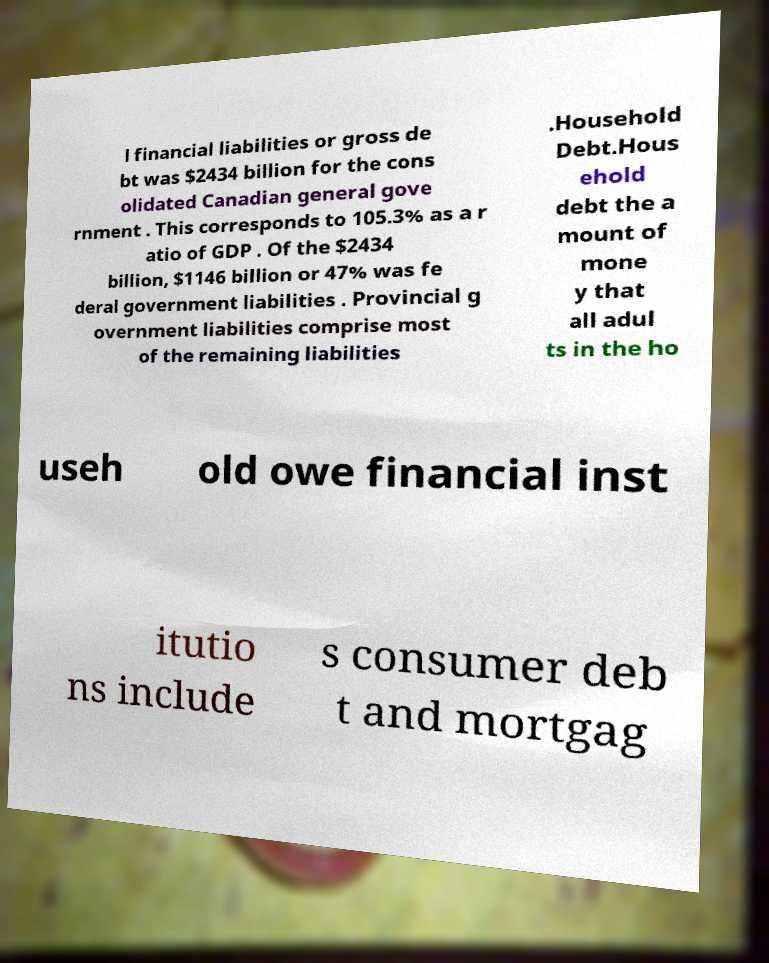Can you accurately transcribe the text from the provided image for me? l financial liabilities or gross de bt was $2434 billion for the cons olidated Canadian general gove rnment . This corresponds to 105.3% as a r atio of GDP . Of the $2434 billion, $1146 billion or 47% was fe deral government liabilities . Provincial g overnment liabilities comprise most of the remaining liabilities .Household Debt.Hous ehold debt the a mount of mone y that all adul ts in the ho useh old owe financial inst itutio ns include s consumer deb t and mortgag 